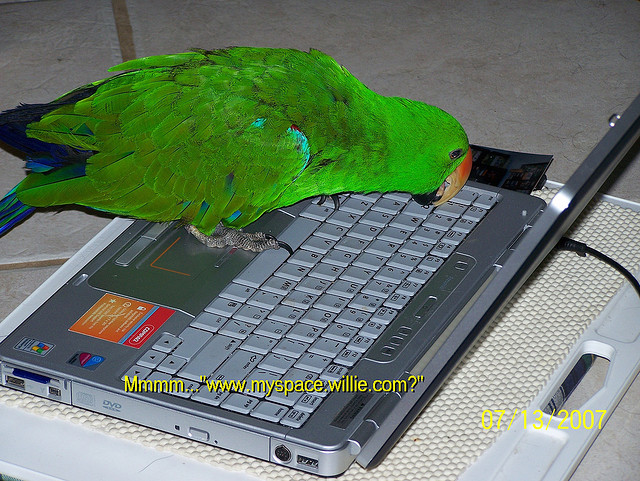Read all the text in this image. Mmmm. www my space willie. .com? 07/13/2007 C M N 8 V 1 2 5 6 7 8 9 0 Q W E R T Y F G H J K L D S A P I U O DVD 